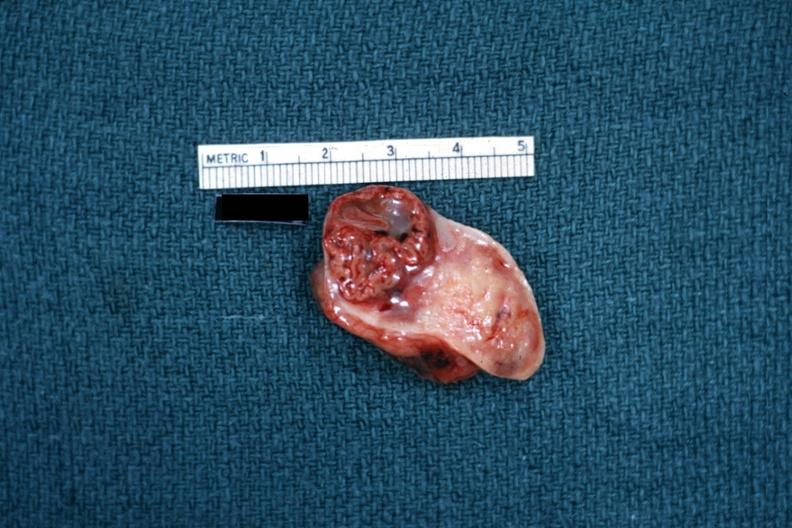does pulmonary osteoarthropathy show excellent example close-up photo of corpus luteum?
Answer the question using a single word or phrase. No 